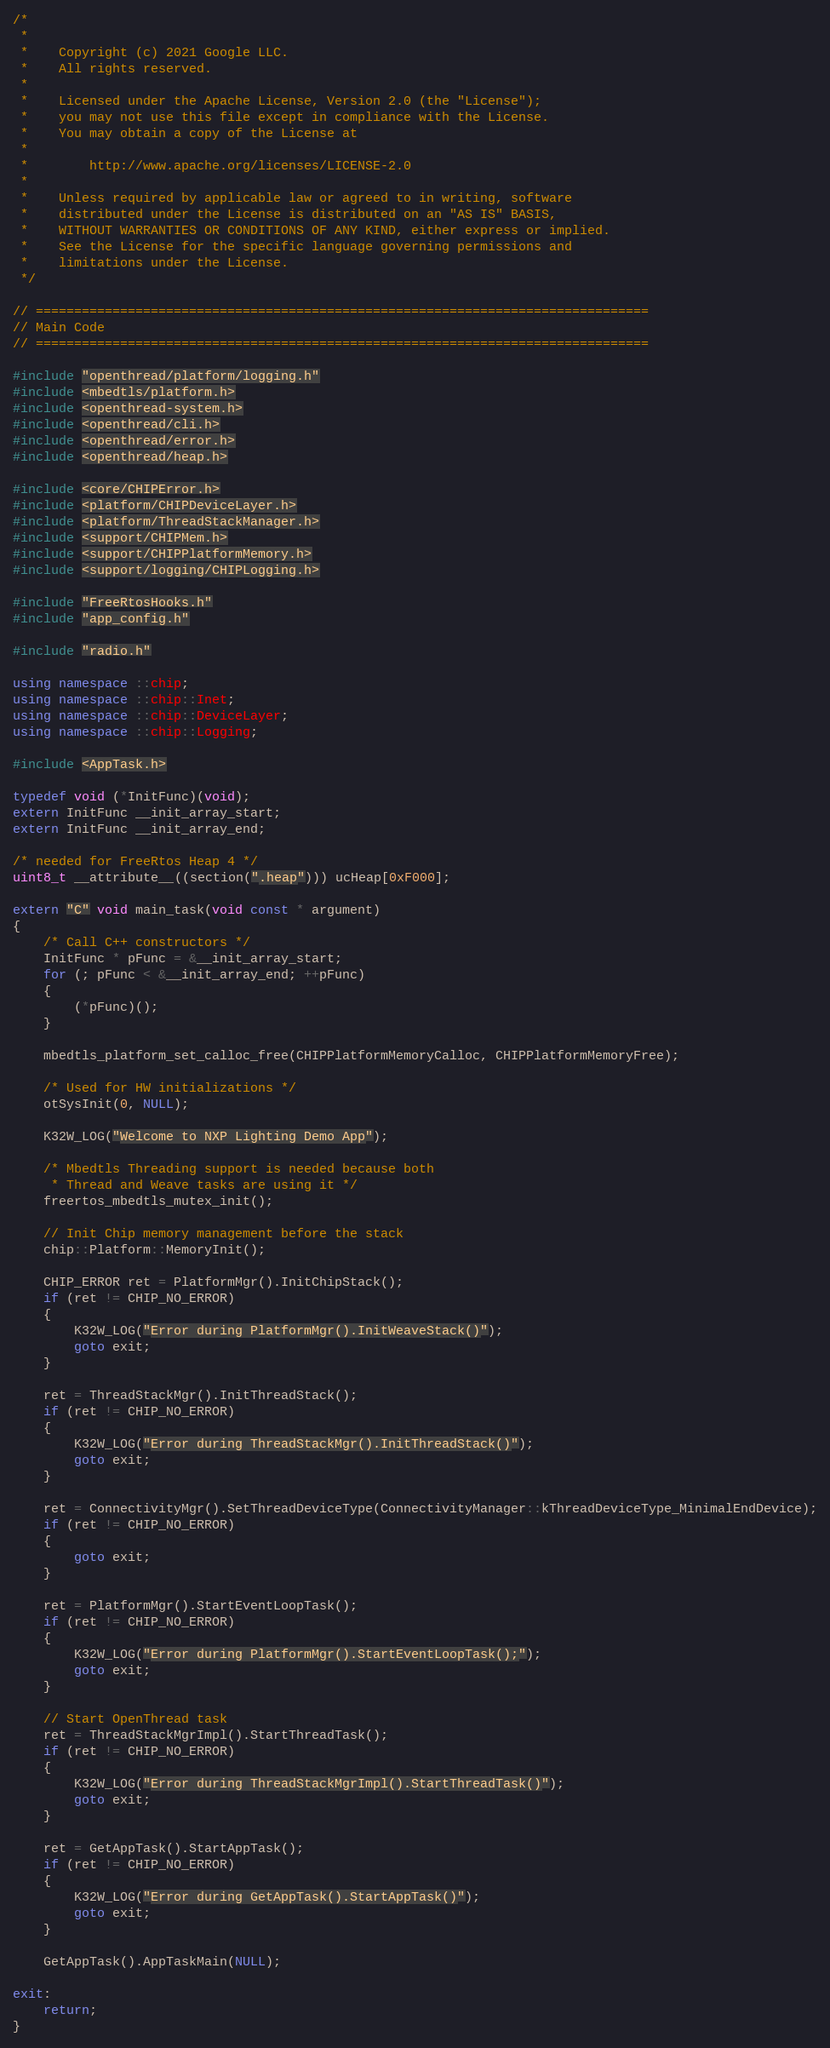Convert code to text. <code><loc_0><loc_0><loc_500><loc_500><_C++_>/*
 *
 *    Copyright (c) 2021 Google LLC.
 *    All rights reserved.
 *
 *    Licensed under the Apache License, Version 2.0 (the "License");
 *    you may not use this file except in compliance with the License.
 *    You may obtain a copy of the License at
 *
 *        http://www.apache.org/licenses/LICENSE-2.0
 *
 *    Unless required by applicable law or agreed to in writing, software
 *    distributed under the License is distributed on an "AS IS" BASIS,
 *    WITHOUT WARRANTIES OR CONDITIONS OF ANY KIND, either express or implied.
 *    See the License for the specific language governing permissions and
 *    limitations under the License.
 */

// ================================================================================
// Main Code
// ================================================================================

#include "openthread/platform/logging.h"
#include <mbedtls/platform.h>
#include <openthread-system.h>
#include <openthread/cli.h>
#include <openthread/error.h>
#include <openthread/heap.h>

#include <core/CHIPError.h>
#include <platform/CHIPDeviceLayer.h>
#include <platform/ThreadStackManager.h>
#include <support/CHIPMem.h>
#include <support/CHIPPlatformMemory.h>
#include <support/logging/CHIPLogging.h>

#include "FreeRtosHooks.h"
#include "app_config.h"

#include "radio.h"

using namespace ::chip;
using namespace ::chip::Inet;
using namespace ::chip::DeviceLayer;
using namespace ::chip::Logging;

#include <AppTask.h>

typedef void (*InitFunc)(void);
extern InitFunc __init_array_start;
extern InitFunc __init_array_end;

/* needed for FreeRtos Heap 4 */
uint8_t __attribute__((section(".heap"))) ucHeap[0xF000];

extern "C" void main_task(void const * argument)
{
    /* Call C++ constructors */
    InitFunc * pFunc = &__init_array_start;
    for (; pFunc < &__init_array_end; ++pFunc)
    {
        (*pFunc)();
    }

    mbedtls_platform_set_calloc_free(CHIPPlatformMemoryCalloc, CHIPPlatformMemoryFree);

    /* Used for HW initializations */
    otSysInit(0, NULL);

    K32W_LOG("Welcome to NXP Lighting Demo App");

    /* Mbedtls Threading support is needed because both
     * Thread and Weave tasks are using it */
    freertos_mbedtls_mutex_init();

    // Init Chip memory management before the stack
    chip::Platform::MemoryInit();

    CHIP_ERROR ret = PlatformMgr().InitChipStack();
    if (ret != CHIP_NO_ERROR)
    {
        K32W_LOG("Error during PlatformMgr().InitWeaveStack()");
        goto exit;
    }

    ret = ThreadStackMgr().InitThreadStack();
    if (ret != CHIP_NO_ERROR)
    {
        K32W_LOG("Error during ThreadStackMgr().InitThreadStack()");
        goto exit;
    }

    ret = ConnectivityMgr().SetThreadDeviceType(ConnectivityManager::kThreadDeviceType_MinimalEndDevice);
    if (ret != CHIP_NO_ERROR)
    {
        goto exit;
    }

    ret = PlatformMgr().StartEventLoopTask();
    if (ret != CHIP_NO_ERROR)
    {
        K32W_LOG("Error during PlatformMgr().StartEventLoopTask();");
        goto exit;
    }

    // Start OpenThread task
    ret = ThreadStackMgrImpl().StartThreadTask();
    if (ret != CHIP_NO_ERROR)
    {
        K32W_LOG("Error during ThreadStackMgrImpl().StartThreadTask()");
        goto exit;
    }

    ret = GetAppTask().StartAppTask();
    if (ret != CHIP_NO_ERROR)
    {
        K32W_LOG("Error during GetAppTask().StartAppTask()");
        goto exit;
    }

    GetAppTask().AppTaskMain(NULL);

exit:
    return;
}
</code> 